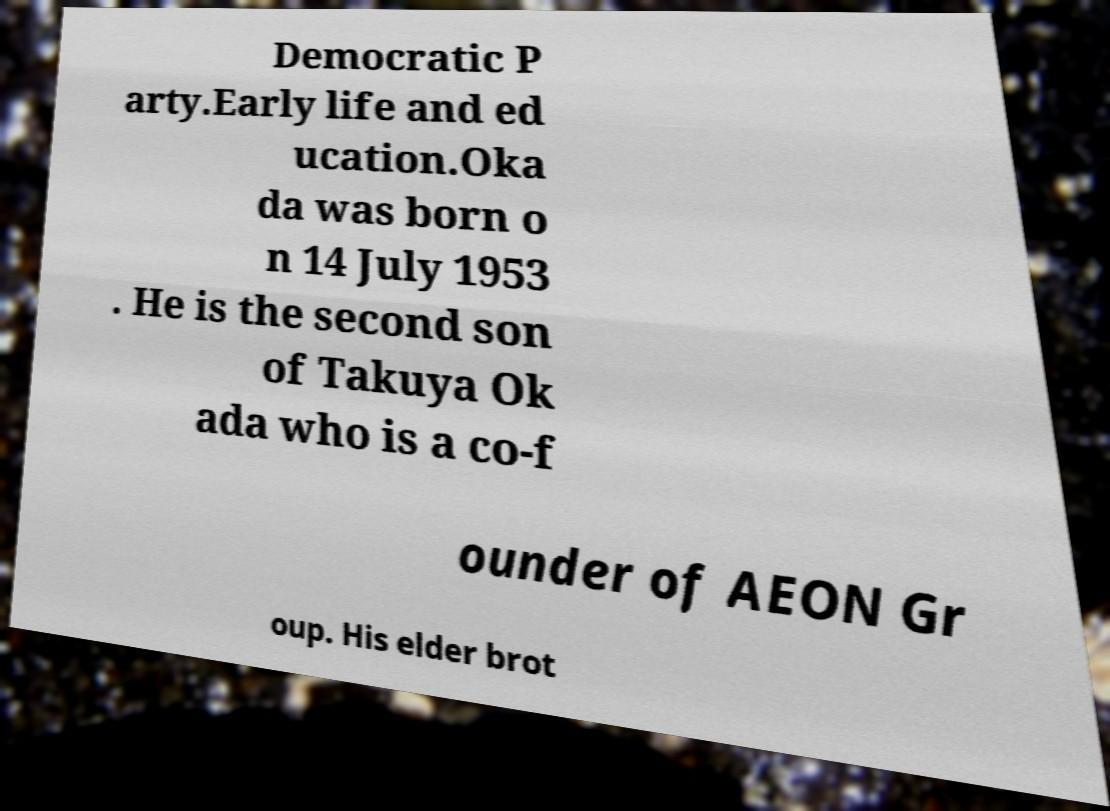Please identify and transcribe the text found in this image. Democratic P arty.Early life and ed ucation.Oka da was born o n 14 July 1953 . He is the second son of Takuya Ok ada who is a co-f ounder of AEON Gr oup. His elder brot 